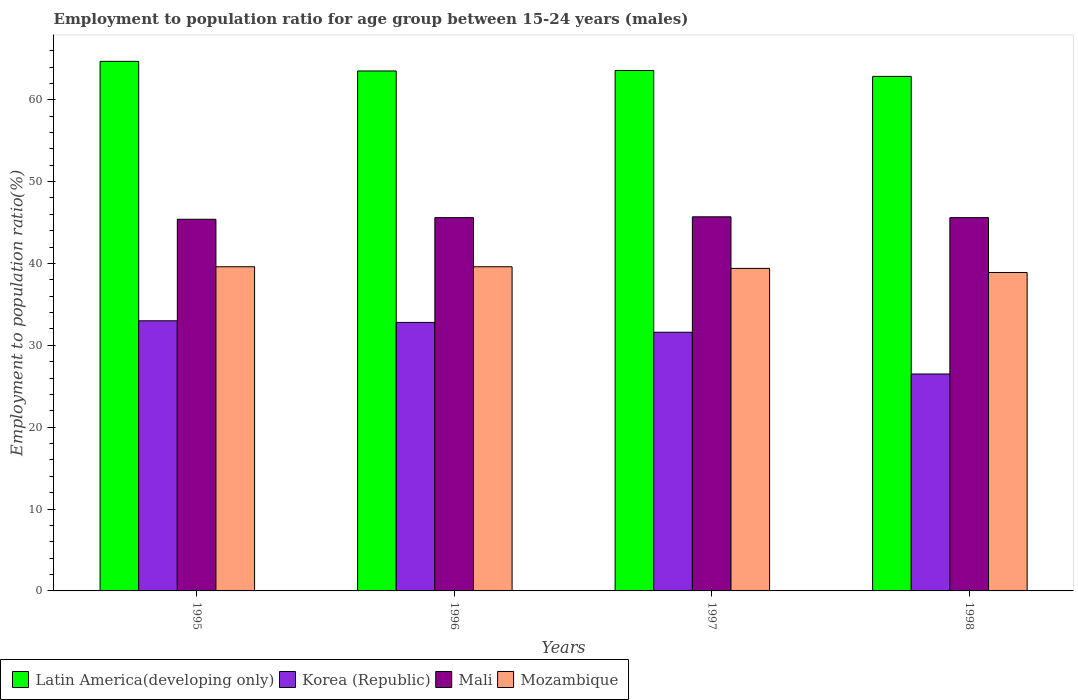How many different coloured bars are there?
Provide a succinct answer. 4. How many groups of bars are there?
Offer a very short reply. 4. Are the number of bars on each tick of the X-axis equal?
Make the answer very short. Yes. How many bars are there on the 2nd tick from the left?
Provide a short and direct response. 4. In how many cases, is the number of bars for a given year not equal to the number of legend labels?
Your answer should be compact. 0. What is the employment to population ratio in Mozambique in 1995?
Offer a very short reply. 39.6. Across all years, what is the maximum employment to population ratio in Mozambique?
Offer a very short reply. 39.6. Across all years, what is the minimum employment to population ratio in Mali?
Make the answer very short. 45.4. In which year was the employment to population ratio in Korea (Republic) maximum?
Give a very brief answer. 1995. In which year was the employment to population ratio in Mozambique minimum?
Your answer should be compact. 1998. What is the total employment to population ratio in Mali in the graph?
Offer a very short reply. 182.3. What is the difference between the employment to population ratio in Mali in 1995 and that in 1998?
Offer a terse response. -0.2. What is the difference between the employment to population ratio in Mozambique in 1996 and the employment to population ratio in Latin America(developing only) in 1995?
Provide a succinct answer. -25.09. What is the average employment to population ratio in Mozambique per year?
Provide a short and direct response. 39.38. In the year 1996, what is the difference between the employment to population ratio in Mozambique and employment to population ratio in Latin America(developing only)?
Ensure brevity in your answer.  -23.92. What is the ratio of the employment to population ratio in Latin America(developing only) in 1995 to that in 1997?
Ensure brevity in your answer.  1.02. Is the difference between the employment to population ratio in Mozambique in 1995 and 1998 greater than the difference between the employment to population ratio in Latin America(developing only) in 1995 and 1998?
Your response must be concise. No. What is the difference between the highest and the second highest employment to population ratio in Korea (Republic)?
Ensure brevity in your answer.  0.2. What is the difference between the highest and the lowest employment to population ratio in Mozambique?
Provide a succinct answer. 0.7. In how many years, is the employment to population ratio in Mali greater than the average employment to population ratio in Mali taken over all years?
Make the answer very short. 3. What does the 3rd bar from the right in 1995 represents?
Keep it short and to the point. Korea (Republic). Is it the case that in every year, the sum of the employment to population ratio in Mozambique and employment to population ratio in Latin America(developing only) is greater than the employment to population ratio in Korea (Republic)?
Your answer should be compact. Yes. How many bars are there?
Provide a short and direct response. 16. How many legend labels are there?
Give a very brief answer. 4. How are the legend labels stacked?
Keep it short and to the point. Horizontal. What is the title of the graph?
Give a very brief answer. Employment to population ratio for age group between 15-24 years (males). What is the label or title of the Y-axis?
Your response must be concise. Employment to population ratio(%). What is the Employment to population ratio(%) of Latin America(developing only) in 1995?
Make the answer very short. 64.69. What is the Employment to population ratio(%) in Korea (Republic) in 1995?
Your answer should be very brief. 33. What is the Employment to population ratio(%) in Mali in 1995?
Provide a short and direct response. 45.4. What is the Employment to population ratio(%) of Mozambique in 1995?
Keep it short and to the point. 39.6. What is the Employment to population ratio(%) in Latin America(developing only) in 1996?
Provide a succinct answer. 63.52. What is the Employment to population ratio(%) of Korea (Republic) in 1996?
Your answer should be very brief. 32.8. What is the Employment to population ratio(%) in Mali in 1996?
Offer a very short reply. 45.6. What is the Employment to population ratio(%) of Mozambique in 1996?
Offer a terse response. 39.6. What is the Employment to population ratio(%) of Latin America(developing only) in 1997?
Offer a terse response. 63.57. What is the Employment to population ratio(%) of Korea (Republic) in 1997?
Keep it short and to the point. 31.6. What is the Employment to population ratio(%) of Mali in 1997?
Offer a terse response. 45.7. What is the Employment to population ratio(%) in Mozambique in 1997?
Your answer should be compact. 39.4. What is the Employment to population ratio(%) in Latin America(developing only) in 1998?
Provide a short and direct response. 62.85. What is the Employment to population ratio(%) in Mali in 1998?
Your response must be concise. 45.6. What is the Employment to population ratio(%) in Mozambique in 1998?
Offer a terse response. 38.9. Across all years, what is the maximum Employment to population ratio(%) of Latin America(developing only)?
Keep it short and to the point. 64.69. Across all years, what is the maximum Employment to population ratio(%) in Mali?
Offer a terse response. 45.7. Across all years, what is the maximum Employment to population ratio(%) of Mozambique?
Ensure brevity in your answer.  39.6. Across all years, what is the minimum Employment to population ratio(%) in Latin America(developing only)?
Provide a short and direct response. 62.85. Across all years, what is the minimum Employment to population ratio(%) of Mali?
Your answer should be compact. 45.4. Across all years, what is the minimum Employment to population ratio(%) of Mozambique?
Make the answer very short. 38.9. What is the total Employment to population ratio(%) of Latin America(developing only) in the graph?
Provide a short and direct response. 254.63. What is the total Employment to population ratio(%) in Korea (Republic) in the graph?
Keep it short and to the point. 123.9. What is the total Employment to population ratio(%) in Mali in the graph?
Provide a short and direct response. 182.3. What is the total Employment to population ratio(%) in Mozambique in the graph?
Your response must be concise. 157.5. What is the difference between the Employment to population ratio(%) of Latin America(developing only) in 1995 and that in 1996?
Make the answer very short. 1.18. What is the difference between the Employment to population ratio(%) in Korea (Republic) in 1995 and that in 1996?
Offer a very short reply. 0.2. What is the difference between the Employment to population ratio(%) of Latin America(developing only) in 1995 and that in 1997?
Your response must be concise. 1.12. What is the difference between the Employment to population ratio(%) of Latin America(developing only) in 1995 and that in 1998?
Your answer should be very brief. 1.84. What is the difference between the Employment to population ratio(%) in Korea (Republic) in 1995 and that in 1998?
Keep it short and to the point. 6.5. What is the difference between the Employment to population ratio(%) of Latin America(developing only) in 1996 and that in 1997?
Your response must be concise. -0.06. What is the difference between the Employment to population ratio(%) of Korea (Republic) in 1996 and that in 1997?
Provide a succinct answer. 1.2. What is the difference between the Employment to population ratio(%) in Mali in 1996 and that in 1997?
Give a very brief answer. -0.1. What is the difference between the Employment to population ratio(%) in Latin America(developing only) in 1996 and that in 1998?
Provide a short and direct response. 0.66. What is the difference between the Employment to population ratio(%) in Korea (Republic) in 1996 and that in 1998?
Ensure brevity in your answer.  6.3. What is the difference between the Employment to population ratio(%) of Mozambique in 1996 and that in 1998?
Offer a very short reply. 0.7. What is the difference between the Employment to population ratio(%) of Latin America(developing only) in 1997 and that in 1998?
Your answer should be compact. 0.72. What is the difference between the Employment to population ratio(%) of Mali in 1997 and that in 1998?
Provide a short and direct response. 0.1. What is the difference between the Employment to population ratio(%) of Latin America(developing only) in 1995 and the Employment to population ratio(%) of Korea (Republic) in 1996?
Keep it short and to the point. 31.89. What is the difference between the Employment to population ratio(%) of Latin America(developing only) in 1995 and the Employment to population ratio(%) of Mali in 1996?
Give a very brief answer. 19.09. What is the difference between the Employment to population ratio(%) of Latin America(developing only) in 1995 and the Employment to population ratio(%) of Mozambique in 1996?
Offer a terse response. 25.09. What is the difference between the Employment to population ratio(%) in Mali in 1995 and the Employment to population ratio(%) in Mozambique in 1996?
Give a very brief answer. 5.8. What is the difference between the Employment to population ratio(%) of Latin America(developing only) in 1995 and the Employment to population ratio(%) of Korea (Republic) in 1997?
Make the answer very short. 33.09. What is the difference between the Employment to population ratio(%) in Latin America(developing only) in 1995 and the Employment to population ratio(%) in Mali in 1997?
Offer a very short reply. 18.99. What is the difference between the Employment to population ratio(%) in Latin America(developing only) in 1995 and the Employment to population ratio(%) in Mozambique in 1997?
Your response must be concise. 25.29. What is the difference between the Employment to population ratio(%) in Korea (Republic) in 1995 and the Employment to population ratio(%) in Mali in 1997?
Offer a very short reply. -12.7. What is the difference between the Employment to population ratio(%) of Latin America(developing only) in 1995 and the Employment to population ratio(%) of Korea (Republic) in 1998?
Provide a short and direct response. 38.19. What is the difference between the Employment to population ratio(%) of Latin America(developing only) in 1995 and the Employment to population ratio(%) of Mali in 1998?
Your answer should be very brief. 19.09. What is the difference between the Employment to population ratio(%) of Latin America(developing only) in 1995 and the Employment to population ratio(%) of Mozambique in 1998?
Provide a succinct answer. 25.79. What is the difference between the Employment to population ratio(%) of Mali in 1995 and the Employment to population ratio(%) of Mozambique in 1998?
Your answer should be compact. 6.5. What is the difference between the Employment to population ratio(%) in Latin America(developing only) in 1996 and the Employment to population ratio(%) in Korea (Republic) in 1997?
Offer a very short reply. 31.92. What is the difference between the Employment to population ratio(%) in Latin America(developing only) in 1996 and the Employment to population ratio(%) in Mali in 1997?
Give a very brief answer. 17.82. What is the difference between the Employment to population ratio(%) of Latin America(developing only) in 1996 and the Employment to population ratio(%) of Mozambique in 1997?
Make the answer very short. 24.12. What is the difference between the Employment to population ratio(%) in Latin America(developing only) in 1996 and the Employment to population ratio(%) in Korea (Republic) in 1998?
Give a very brief answer. 37.02. What is the difference between the Employment to population ratio(%) of Latin America(developing only) in 1996 and the Employment to population ratio(%) of Mali in 1998?
Offer a terse response. 17.92. What is the difference between the Employment to population ratio(%) of Latin America(developing only) in 1996 and the Employment to population ratio(%) of Mozambique in 1998?
Provide a short and direct response. 24.62. What is the difference between the Employment to population ratio(%) of Korea (Republic) in 1996 and the Employment to population ratio(%) of Mozambique in 1998?
Provide a short and direct response. -6.1. What is the difference between the Employment to population ratio(%) of Mali in 1996 and the Employment to population ratio(%) of Mozambique in 1998?
Provide a succinct answer. 6.7. What is the difference between the Employment to population ratio(%) in Latin America(developing only) in 1997 and the Employment to population ratio(%) in Korea (Republic) in 1998?
Provide a succinct answer. 37.07. What is the difference between the Employment to population ratio(%) of Latin America(developing only) in 1997 and the Employment to population ratio(%) of Mali in 1998?
Make the answer very short. 17.97. What is the difference between the Employment to population ratio(%) of Latin America(developing only) in 1997 and the Employment to population ratio(%) of Mozambique in 1998?
Provide a short and direct response. 24.67. What is the difference between the Employment to population ratio(%) of Korea (Republic) in 1997 and the Employment to population ratio(%) of Mali in 1998?
Your answer should be compact. -14. What is the difference between the Employment to population ratio(%) in Mali in 1997 and the Employment to population ratio(%) in Mozambique in 1998?
Give a very brief answer. 6.8. What is the average Employment to population ratio(%) of Latin America(developing only) per year?
Your response must be concise. 63.66. What is the average Employment to population ratio(%) of Korea (Republic) per year?
Provide a succinct answer. 30.98. What is the average Employment to population ratio(%) in Mali per year?
Offer a terse response. 45.58. What is the average Employment to population ratio(%) of Mozambique per year?
Provide a succinct answer. 39.38. In the year 1995, what is the difference between the Employment to population ratio(%) of Latin America(developing only) and Employment to population ratio(%) of Korea (Republic)?
Give a very brief answer. 31.69. In the year 1995, what is the difference between the Employment to population ratio(%) in Latin America(developing only) and Employment to population ratio(%) in Mali?
Your response must be concise. 19.29. In the year 1995, what is the difference between the Employment to population ratio(%) of Latin America(developing only) and Employment to population ratio(%) of Mozambique?
Your response must be concise. 25.09. In the year 1995, what is the difference between the Employment to population ratio(%) in Korea (Republic) and Employment to population ratio(%) in Mali?
Provide a succinct answer. -12.4. In the year 1995, what is the difference between the Employment to population ratio(%) in Mali and Employment to population ratio(%) in Mozambique?
Offer a terse response. 5.8. In the year 1996, what is the difference between the Employment to population ratio(%) in Latin America(developing only) and Employment to population ratio(%) in Korea (Republic)?
Give a very brief answer. 30.72. In the year 1996, what is the difference between the Employment to population ratio(%) in Latin America(developing only) and Employment to population ratio(%) in Mali?
Provide a short and direct response. 17.92. In the year 1996, what is the difference between the Employment to population ratio(%) in Latin America(developing only) and Employment to population ratio(%) in Mozambique?
Give a very brief answer. 23.92. In the year 1996, what is the difference between the Employment to population ratio(%) in Korea (Republic) and Employment to population ratio(%) in Mali?
Your response must be concise. -12.8. In the year 1996, what is the difference between the Employment to population ratio(%) in Korea (Republic) and Employment to population ratio(%) in Mozambique?
Offer a terse response. -6.8. In the year 1996, what is the difference between the Employment to population ratio(%) of Mali and Employment to population ratio(%) of Mozambique?
Offer a terse response. 6. In the year 1997, what is the difference between the Employment to population ratio(%) of Latin America(developing only) and Employment to population ratio(%) of Korea (Republic)?
Provide a succinct answer. 31.97. In the year 1997, what is the difference between the Employment to population ratio(%) in Latin America(developing only) and Employment to population ratio(%) in Mali?
Provide a short and direct response. 17.87. In the year 1997, what is the difference between the Employment to population ratio(%) of Latin America(developing only) and Employment to population ratio(%) of Mozambique?
Your response must be concise. 24.17. In the year 1997, what is the difference between the Employment to population ratio(%) of Korea (Republic) and Employment to population ratio(%) of Mali?
Offer a very short reply. -14.1. In the year 1997, what is the difference between the Employment to population ratio(%) in Korea (Republic) and Employment to population ratio(%) in Mozambique?
Keep it short and to the point. -7.8. In the year 1998, what is the difference between the Employment to population ratio(%) of Latin America(developing only) and Employment to population ratio(%) of Korea (Republic)?
Offer a very short reply. 36.35. In the year 1998, what is the difference between the Employment to population ratio(%) in Latin America(developing only) and Employment to population ratio(%) in Mali?
Provide a short and direct response. 17.25. In the year 1998, what is the difference between the Employment to population ratio(%) of Latin America(developing only) and Employment to population ratio(%) of Mozambique?
Give a very brief answer. 23.95. In the year 1998, what is the difference between the Employment to population ratio(%) of Korea (Republic) and Employment to population ratio(%) of Mali?
Keep it short and to the point. -19.1. In the year 1998, what is the difference between the Employment to population ratio(%) in Korea (Republic) and Employment to population ratio(%) in Mozambique?
Give a very brief answer. -12.4. What is the ratio of the Employment to population ratio(%) in Latin America(developing only) in 1995 to that in 1996?
Your response must be concise. 1.02. What is the ratio of the Employment to population ratio(%) in Mali in 1995 to that in 1996?
Provide a succinct answer. 1. What is the ratio of the Employment to population ratio(%) of Latin America(developing only) in 1995 to that in 1997?
Your answer should be very brief. 1.02. What is the ratio of the Employment to population ratio(%) in Korea (Republic) in 1995 to that in 1997?
Give a very brief answer. 1.04. What is the ratio of the Employment to population ratio(%) of Latin America(developing only) in 1995 to that in 1998?
Provide a short and direct response. 1.03. What is the ratio of the Employment to population ratio(%) in Korea (Republic) in 1995 to that in 1998?
Your answer should be very brief. 1.25. What is the ratio of the Employment to population ratio(%) in Mali in 1995 to that in 1998?
Provide a short and direct response. 1. What is the ratio of the Employment to population ratio(%) in Mozambique in 1995 to that in 1998?
Offer a very short reply. 1.02. What is the ratio of the Employment to population ratio(%) in Latin America(developing only) in 1996 to that in 1997?
Your answer should be compact. 1. What is the ratio of the Employment to population ratio(%) in Korea (Republic) in 1996 to that in 1997?
Provide a succinct answer. 1.04. What is the ratio of the Employment to population ratio(%) in Latin America(developing only) in 1996 to that in 1998?
Make the answer very short. 1.01. What is the ratio of the Employment to population ratio(%) in Korea (Republic) in 1996 to that in 1998?
Ensure brevity in your answer.  1.24. What is the ratio of the Employment to population ratio(%) in Mali in 1996 to that in 1998?
Offer a very short reply. 1. What is the ratio of the Employment to population ratio(%) in Latin America(developing only) in 1997 to that in 1998?
Make the answer very short. 1.01. What is the ratio of the Employment to population ratio(%) of Korea (Republic) in 1997 to that in 1998?
Ensure brevity in your answer.  1.19. What is the ratio of the Employment to population ratio(%) of Mali in 1997 to that in 1998?
Give a very brief answer. 1. What is the ratio of the Employment to population ratio(%) in Mozambique in 1997 to that in 1998?
Your answer should be compact. 1.01. What is the difference between the highest and the second highest Employment to population ratio(%) of Latin America(developing only)?
Keep it short and to the point. 1.12. What is the difference between the highest and the second highest Employment to population ratio(%) in Mali?
Provide a succinct answer. 0.1. What is the difference between the highest and the second highest Employment to population ratio(%) in Mozambique?
Offer a terse response. 0. What is the difference between the highest and the lowest Employment to population ratio(%) in Latin America(developing only)?
Offer a terse response. 1.84. What is the difference between the highest and the lowest Employment to population ratio(%) in Korea (Republic)?
Your answer should be very brief. 6.5. What is the difference between the highest and the lowest Employment to population ratio(%) of Mali?
Your answer should be compact. 0.3. What is the difference between the highest and the lowest Employment to population ratio(%) in Mozambique?
Your answer should be very brief. 0.7. 